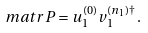<formula> <loc_0><loc_0><loc_500><loc_500>\ m a t r P = u _ { 1 } ^ { ( 0 ) } v _ { 1 } ^ { ( n _ { 1 } ) \dagger } \, .</formula> 